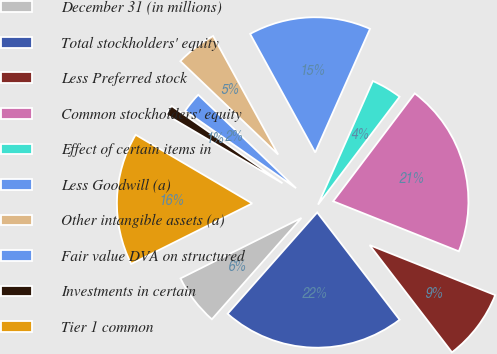Convert chart to OTSL. <chart><loc_0><loc_0><loc_500><loc_500><pie_chart><fcel>December 31 (in millions)<fcel>Total stockholders' equity<fcel>Less Preferred stock<fcel>Common stockholders' equity<fcel>Effect of certain items in<fcel>Less Goodwill (a)<fcel>Other intangible assets (a)<fcel>Fair value DVA on structured<fcel>Investments in certain<fcel>Tier 1 common<nl><fcel>6.1%<fcel>21.95%<fcel>8.54%<fcel>20.73%<fcel>3.66%<fcel>14.63%<fcel>4.88%<fcel>2.44%<fcel>1.22%<fcel>15.85%<nl></chart> 